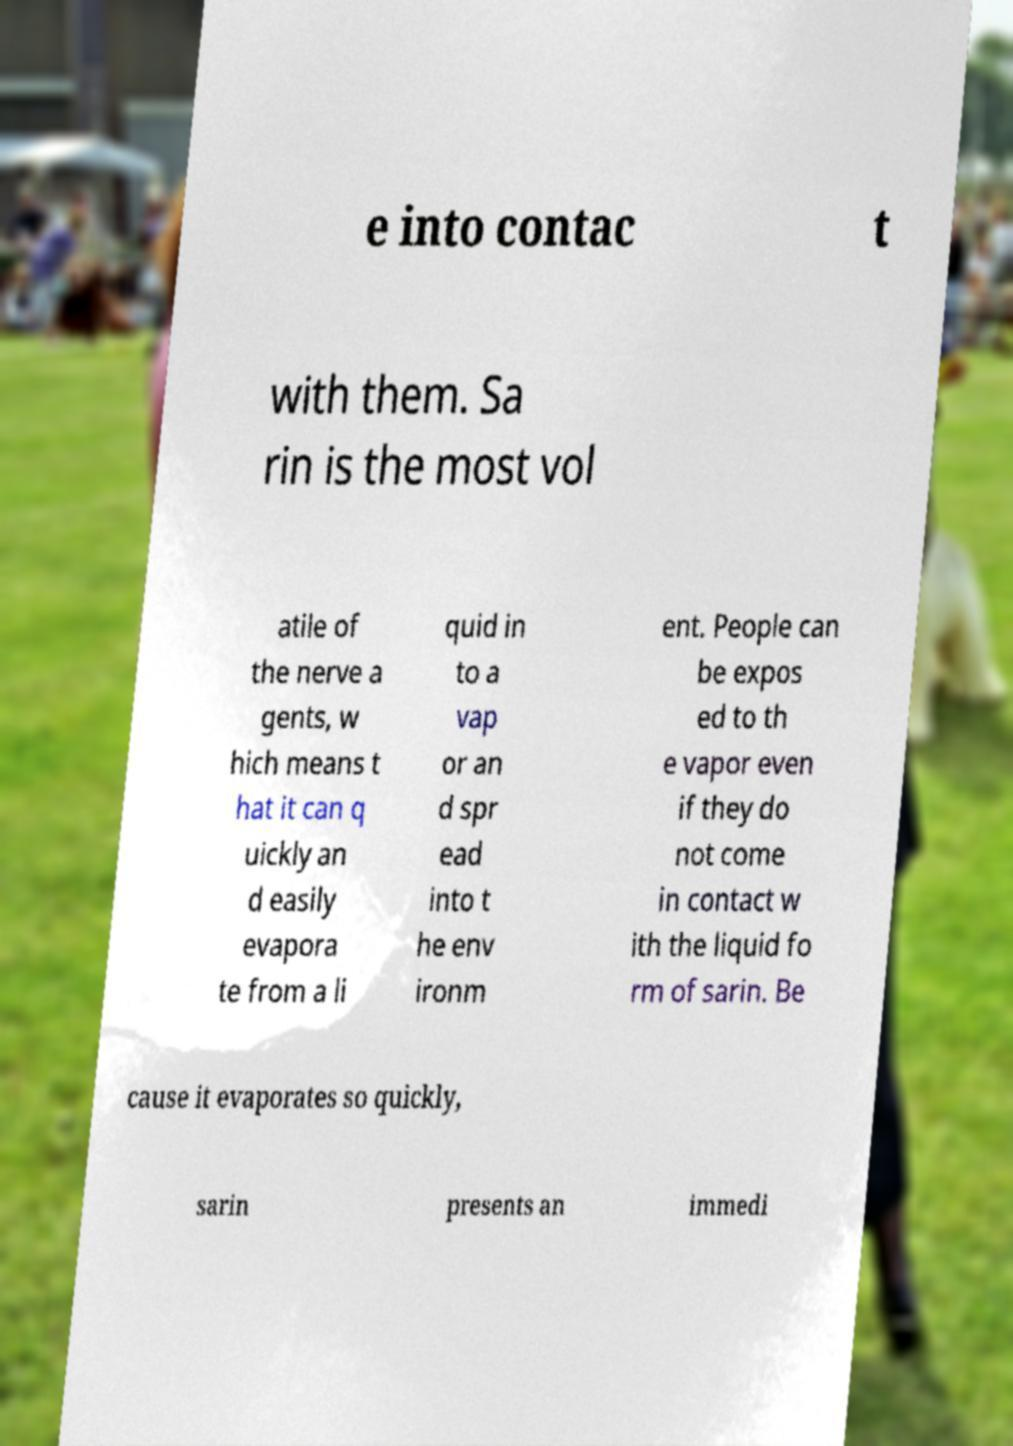There's text embedded in this image that I need extracted. Can you transcribe it verbatim? e into contac t with them. Sa rin is the most vol atile of the nerve a gents, w hich means t hat it can q uickly an d easily evapora te from a li quid in to a vap or an d spr ead into t he env ironm ent. People can be expos ed to th e vapor even if they do not come in contact w ith the liquid fo rm of sarin. Be cause it evaporates so quickly, sarin presents an immedi 